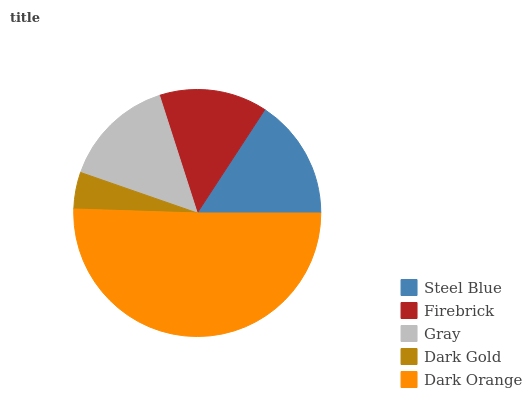Is Dark Gold the minimum?
Answer yes or no. Yes. Is Dark Orange the maximum?
Answer yes or no. Yes. Is Firebrick the minimum?
Answer yes or no. No. Is Firebrick the maximum?
Answer yes or no. No. Is Steel Blue greater than Firebrick?
Answer yes or no. Yes. Is Firebrick less than Steel Blue?
Answer yes or no. Yes. Is Firebrick greater than Steel Blue?
Answer yes or no. No. Is Steel Blue less than Firebrick?
Answer yes or no. No. Is Gray the high median?
Answer yes or no. Yes. Is Gray the low median?
Answer yes or no. Yes. Is Dark Orange the high median?
Answer yes or no. No. Is Steel Blue the low median?
Answer yes or no. No. 